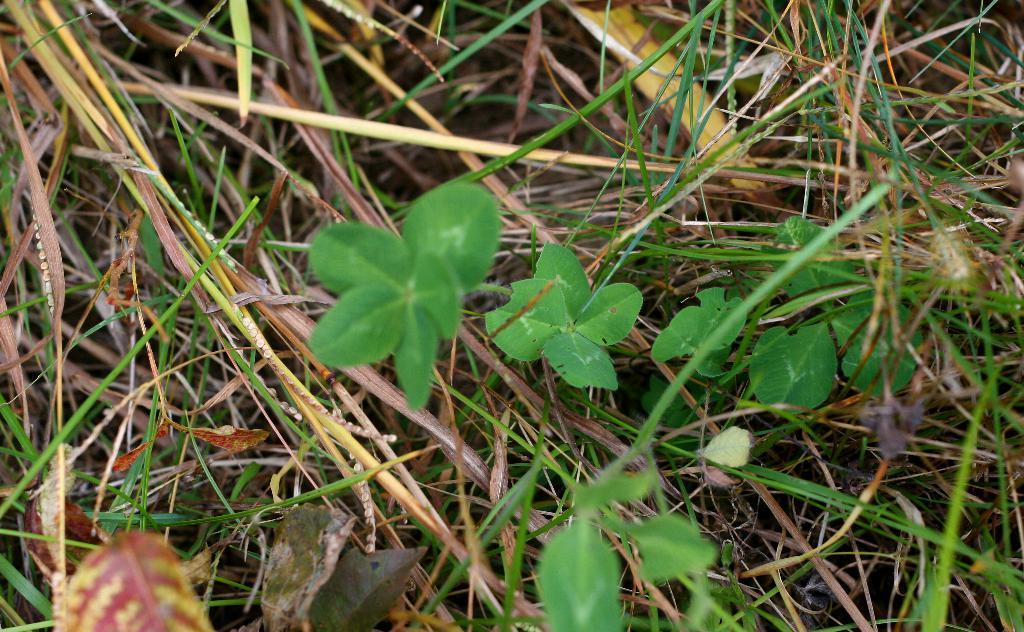What type of plant material can be seen in the image? There are leaves of some plants in the image. What type of store is being advertised in the image? There is no store or advertisement present in the image; it only features leaves of some plants. 